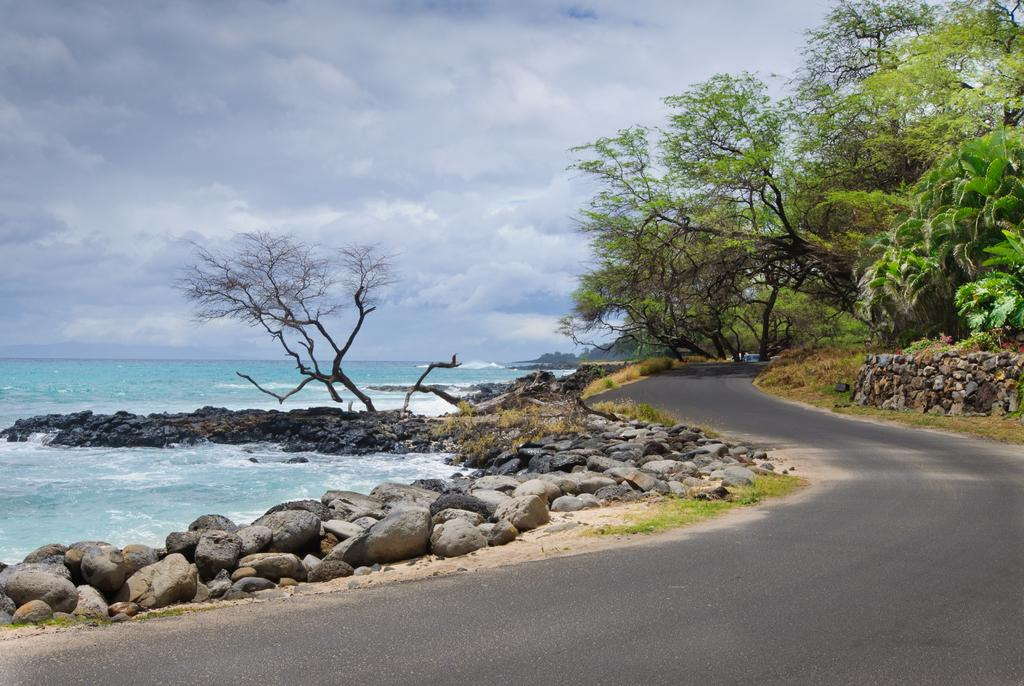What is the main feature of the image? There is a road in the image. What can be seen on the left side of the road? There are rocks on the left side of the image. What is present on the right side of the road? There are trees on the right side of the image. What is visible in the sky in the image? There are clouds in the sky in the image. What is visible in the image besides the road and surrounding features? There is water visible in the image. Can you see any oil spills on the road in the image? There is no mention of an oil spill in the image, so we cannot determine if there is one present. 